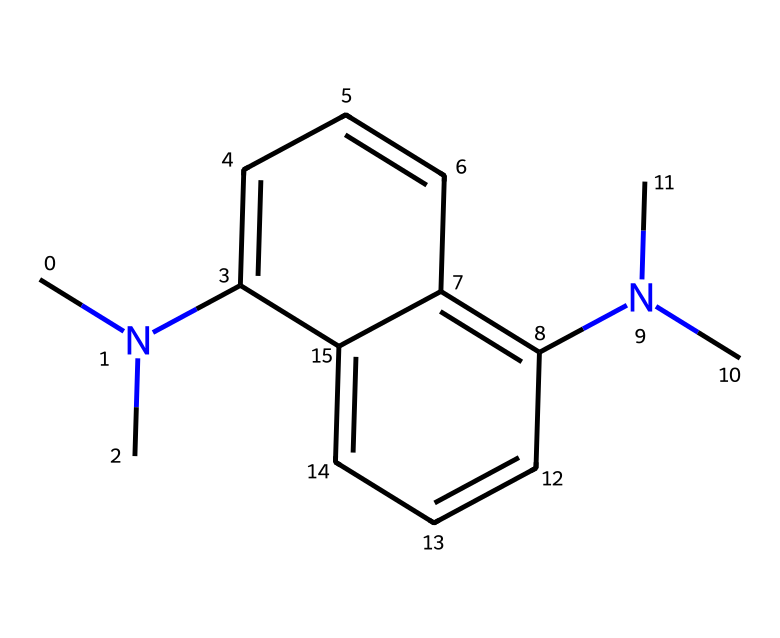What is the total number of nitrogen atoms in this chemical structure? By examining the SMILES representation, we can identify nitrogen atoms by looking for the symbol 'N'. In this structure, there are two 'N' symbols present.
Answer: 2 How many carbon atoms are present in this molecule? The molecule's carbon atoms can be counted from the SMILES notation, where 'C' represents carbon. There are a total of thirteen carbon atoms displayed in this representation.
Answer: 13 What type of chemical compound is indicated by the presence of proton sponges in this structure? Proton sponges are typically classified as superbases; this term describes compounds that have the ability to deprotonate weak acids significantly.
Answer: superbases What is the molecular formula derived from this compound? By analyzing the SMILES structure, we determine the counts for carbon (C), hydrogen (H), and nitrogen (N) atoms and compile them into a formula. The molecular formula is C13H18N2.
Answer: C13H18N2 What functional group is associated with the properties of superbases in this structure? The presence of amine groups indicated by the nitrogen atoms (N) connected to carbon suggests that this compound has amine functional groups. These groups contribute to the basicity of the superbases.
Answer: amine 